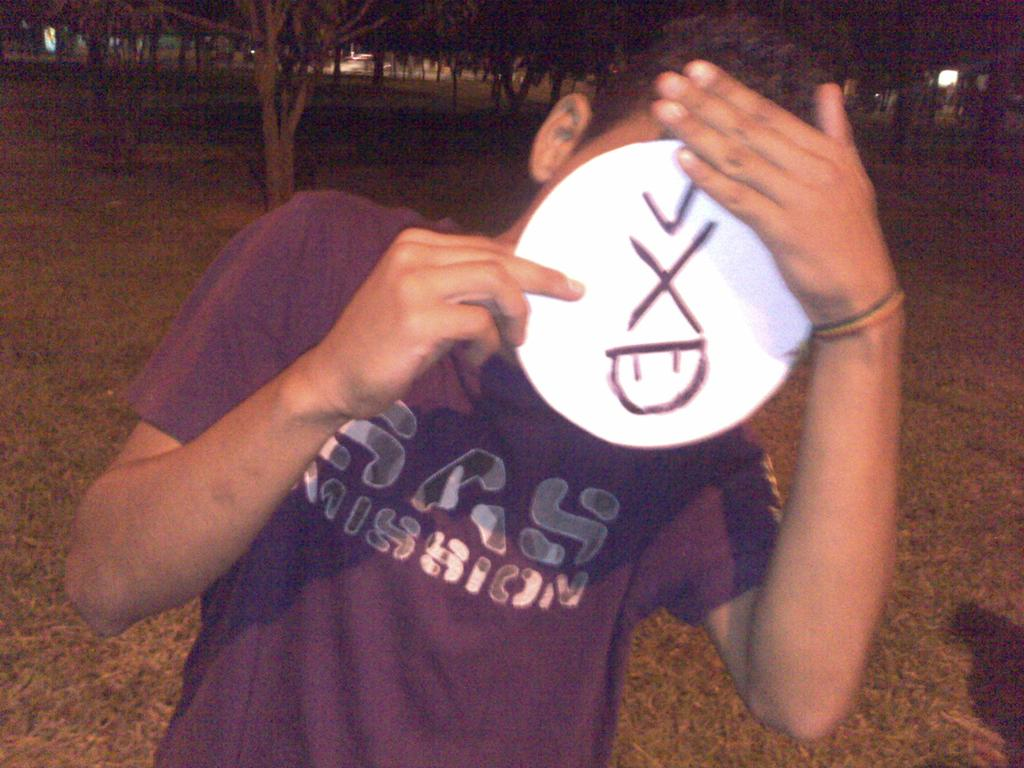<image>
Give a short and clear explanation of the subsequent image. the letter x that is on a white item 